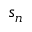Convert formula to latex. <formula><loc_0><loc_0><loc_500><loc_500>s _ { n }</formula> 